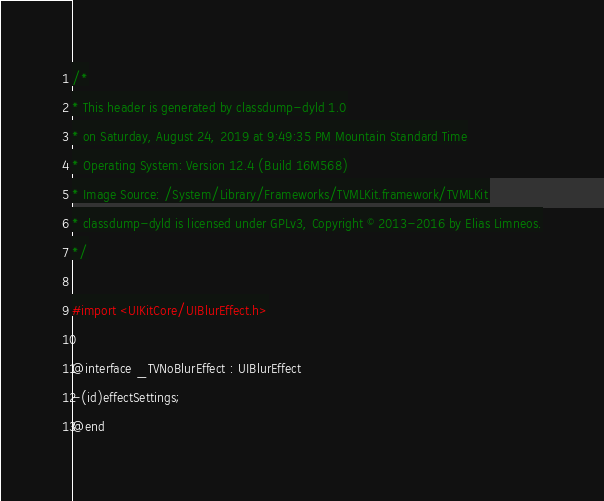<code> <loc_0><loc_0><loc_500><loc_500><_C_>/*
* This header is generated by classdump-dyld 1.0
* on Saturday, August 24, 2019 at 9:49:35 PM Mountain Standard Time
* Operating System: Version 12.4 (Build 16M568)
* Image Source: /System/Library/Frameworks/TVMLKit.framework/TVMLKit
* classdump-dyld is licensed under GPLv3, Copyright © 2013-2016 by Elias Limneos.
*/

#import <UIKitCore/UIBlurEffect.h>

@interface _TVNoBlurEffect : UIBlurEffect
-(id)effectSettings;
@end

</code> 